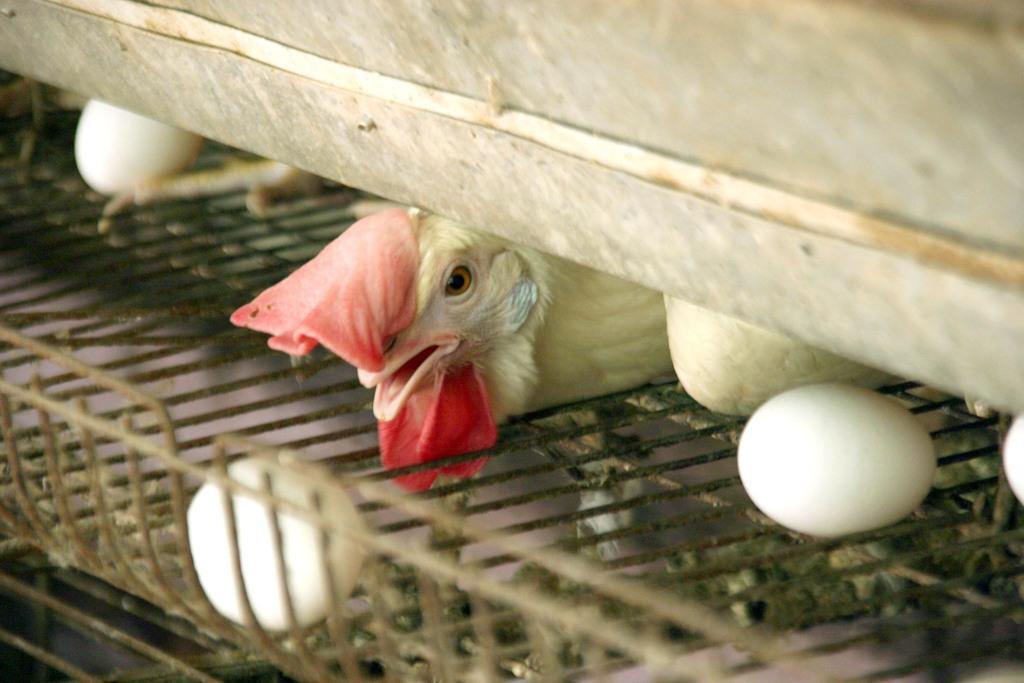Please provide a concise description of this image. In this image there are eggs on the cage and there is a bird. 